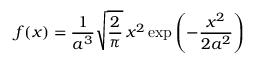<formula> <loc_0><loc_0><loc_500><loc_500>f ( x ) = { \frac { 1 } { a ^ { 3 } } } { \sqrt { \frac { 2 } { \pi } } } \, x ^ { 2 } \exp \left ( - { \frac { x ^ { 2 } } { 2 a ^ { 2 } } } \right )</formula> 